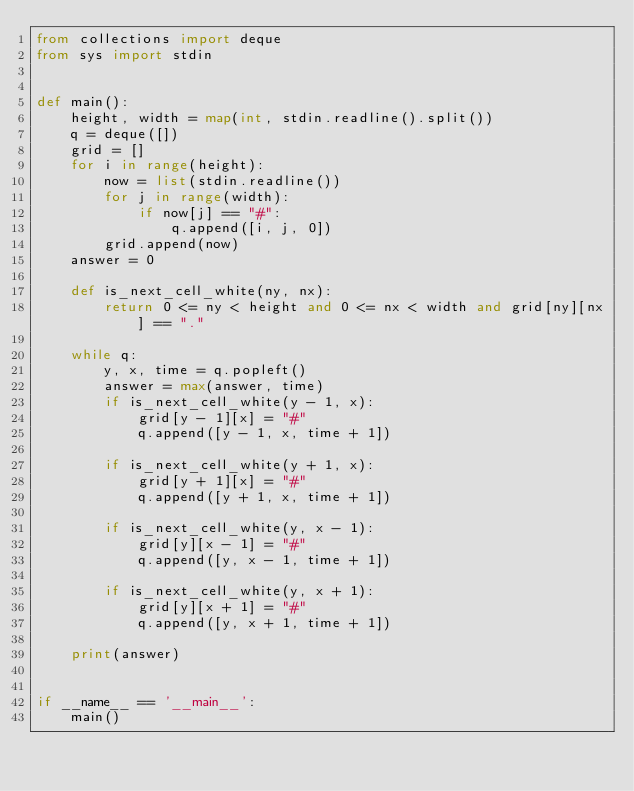<code> <loc_0><loc_0><loc_500><loc_500><_Python_>from collections import deque
from sys import stdin


def main():
    height, width = map(int, stdin.readline().split())
    q = deque([])
    grid = []
    for i in range(height):
        now = list(stdin.readline())
        for j in range(width):
            if now[j] == "#":
                q.append([i, j, 0])
        grid.append(now)
    answer = 0

    def is_next_cell_white(ny, nx):
        return 0 <= ny < height and 0 <= nx < width and grid[ny][nx] == "."

    while q:
        y, x, time = q.popleft()
        answer = max(answer, time)
        if is_next_cell_white(y - 1, x):
            grid[y - 1][x] = "#"
            q.append([y - 1, x, time + 1])

        if is_next_cell_white(y + 1, x):
            grid[y + 1][x] = "#"
            q.append([y + 1, x, time + 1])

        if is_next_cell_white(y, x - 1):
            grid[y][x - 1] = "#"
            q.append([y, x - 1, time + 1])

        if is_next_cell_white(y, x + 1):
            grid[y][x + 1] = "#"
            q.append([y, x + 1, time + 1])

    print(answer)


if __name__ == '__main__':
    main()

</code> 